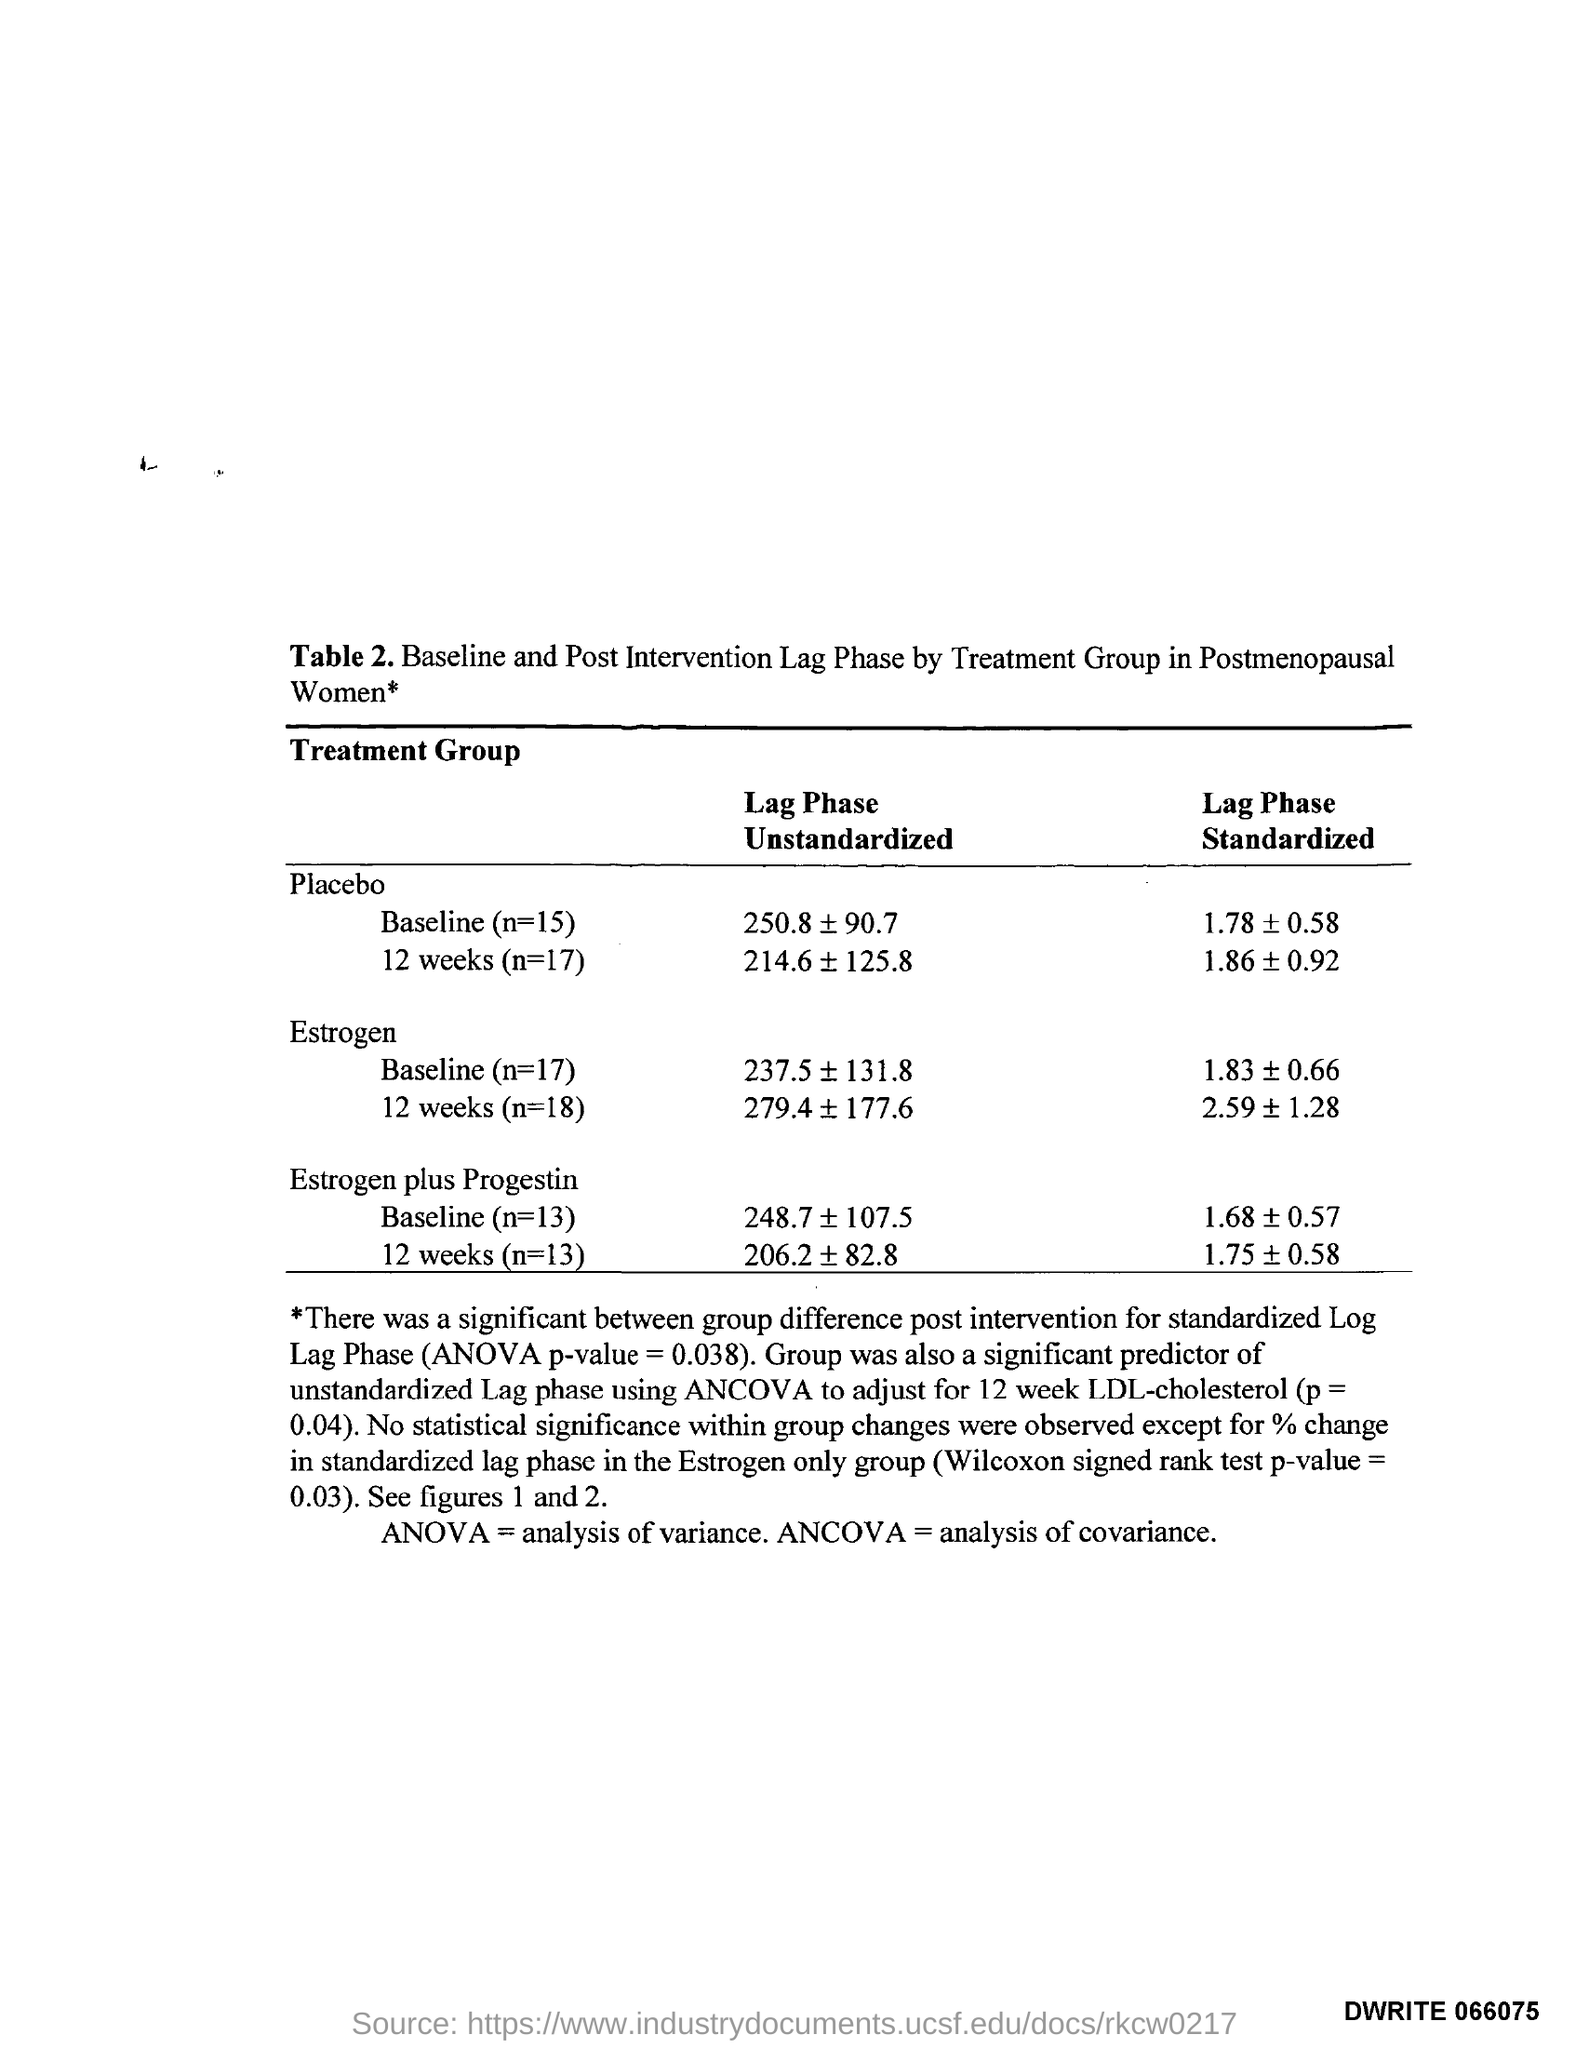Highlight a few significant elements in this photo. ANOVA, or analysis of variance, is a statistical method used to compare the means of multiple groups to determine if there are significant differences among them. ANCOVA stands for Analysis of Covariance, which is a statistical method used to analyze the relationship between a dependent variable and one or more independent variables while controlling for the effect of other variables. 